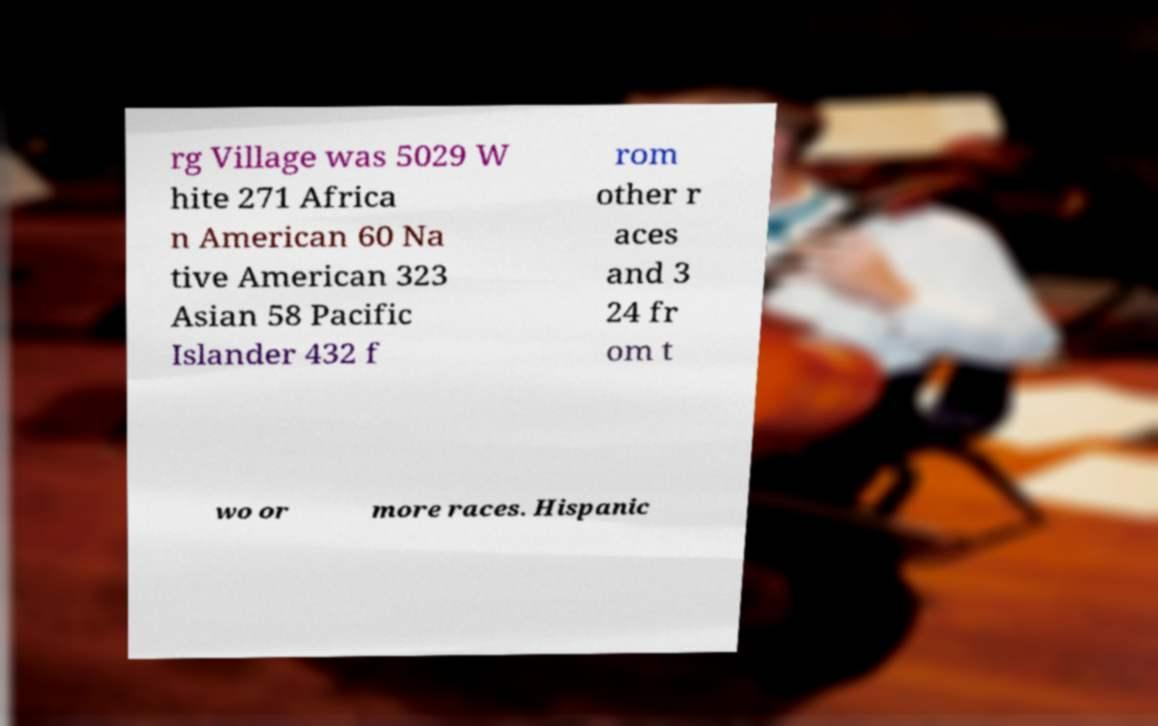There's text embedded in this image that I need extracted. Can you transcribe it verbatim? rg Village was 5029 W hite 271 Africa n American 60 Na tive American 323 Asian 58 Pacific Islander 432 f rom other r aces and 3 24 fr om t wo or more races. Hispanic 